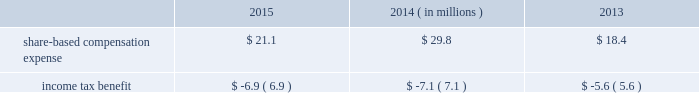During fiscal 2013 , we entered into an asr with a financial institution to repurchase an aggregate of $ 125 million of our common stock .
In exchange for an up-front payment of $ 125 million , the financial institution committed to deliver a number of shares during the asr 2019s purchase period , which ended on march 30 , 2013 .
The total number of shares delivered under this asr was 2.5 million at an average price of $ 49.13 per share .
During fiscal 2013 , in addition to shares repurchased under the asr , we repurchased and retired 1.1 million shares of our common stock at a cost of $ 50.3 million , or an average of $ 44.55 per share , including commissions .
Note 10 2014share-based awards and options non-qualified stock options and restricted stock have been granted to officers , key employees and directors under the global payments inc .
2000 long-term incentive plan , as amended and restated ( the 201c2000 plan 201d ) , the global payments inc .
Amended and restated 2005 incentive plan ( the 201c2005 plan 201d ) , the amended and restated 2000 non-employee director stock option plan ( the 201cdirector stock option plan 201d ) , and the global payments inc .
2011 incentive plan ( the 201c2011 plan 201d ) ( collectively , the 201cplans 201d ) .
There were no further grants made under the 2000 plan after the 2005 plan was effective , and the director stock option plan expired by its terms on february 1 , 2011 .
There will be no future grants under the 2000 plan , the 2005 plan or the director stock option the 2011 plan permits grants of equity to employees , officers , directors and consultants .
A total of 7.0 million shares of our common stock was reserved and made available for issuance pursuant to awards granted under the 2011 plan .
The table summarizes share-based compensation expense and the related income tax benefit recognized for stock options , restricted stock , performance units , tsr units , and shares issued under our employee stock purchase plan ( each as described below ) .
2015 2014 2013 ( in millions ) .
We grant various share-based awards pursuant to the plans under what we refer to as our 201clong-term incentive plan . 201d the awards are held in escrow and released upon the grantee 2019s satisfaction of conditions of the award certificate .
Restricted stock and restricted stock units we grant restricted stock and restricted stock units .
Restricted stock awards vest over a period of time , provided , however , that if the grantee is not employed by us on the vesting date , the shares are forfeited .
Restricted shares cannot be sold or transferred until they have vested .
Restricted stock granted before fiscal 2015 vests in equal installments on each of the first four anniversaries of the grant date .
Restricted stock granted during fiscal 2015 will either vest in equal installments on each of the first three anniversaries of the grant date or cliff vest at the end of a three-year service period .
The grant date fair value of restricted stock , which is based on the quoted market value of our common stock at the closing of the award date , is recognized as share-based compensation expense on a straight-line basis over the vesting period .
Performance units certain of our executives have been granted up to three types of performance units under our long-term incentive plan .
Performance units are performance-based restricted stock units that , after a performance period , convert into common shares , which may be restricted .
The number of shares is dependent upon the achievement of certain performance measures during the performance period .
The target number of performance units and any market-based performance measures ( 201cat threshold , 201d 201ctarget , 201d and 201cmaximum 201d ) are set by the compensation committee of our board of directors .
Performance units are converted only after the compensation committee certifies performance based on pre-established goals .
80 2013 global payments inc .
| 2015 form 10-k annual report .
What is the growth rate in the share-based compensation expense from 2014 to 2015? 
Computations: ((21.1 - 29.8) / 29.8)
Answer: -0.29195. 